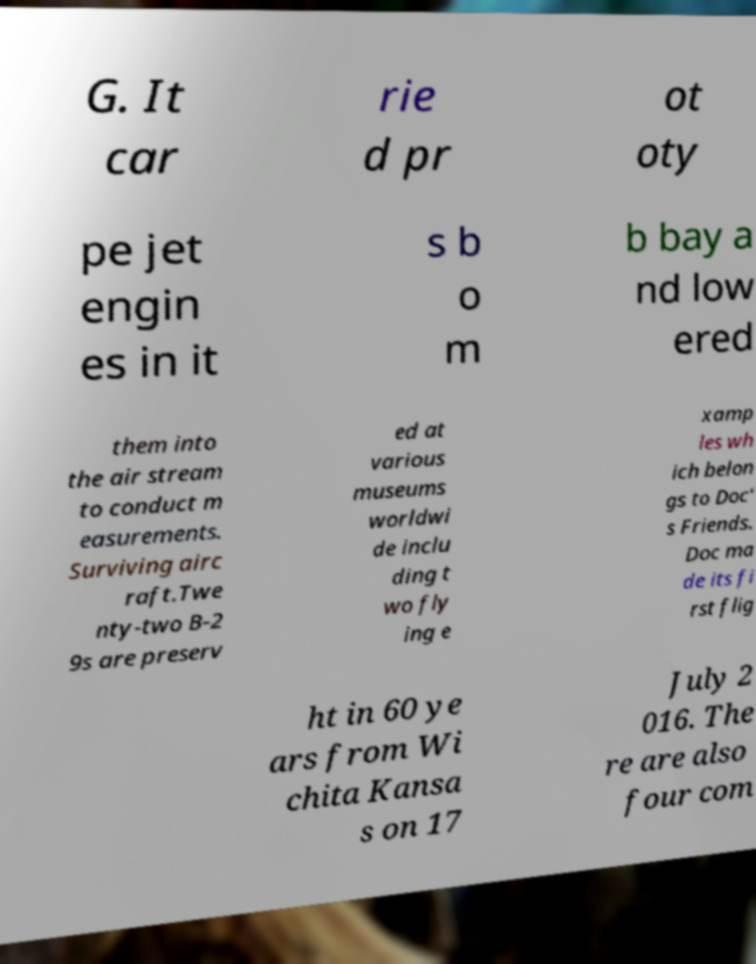What messages or text are displayed in this image? I need them in a readable, typed format. G. It car rie d pr ot oty pe jet engin es in it s b o m b bay a nd low ered them into the air stream to conduct m easurements. Surviving airc raft.Twe nty-two B-2 9s are preserv ed at various museums worldwi de inclu ding t wo fly ing e xamp les wh ich belon gs to Doc' s Friends. Doc ma de its fi rst flig ht in 60 ye ars from Wi chita Kansa s on 17 July 2 016. The re are also four com 